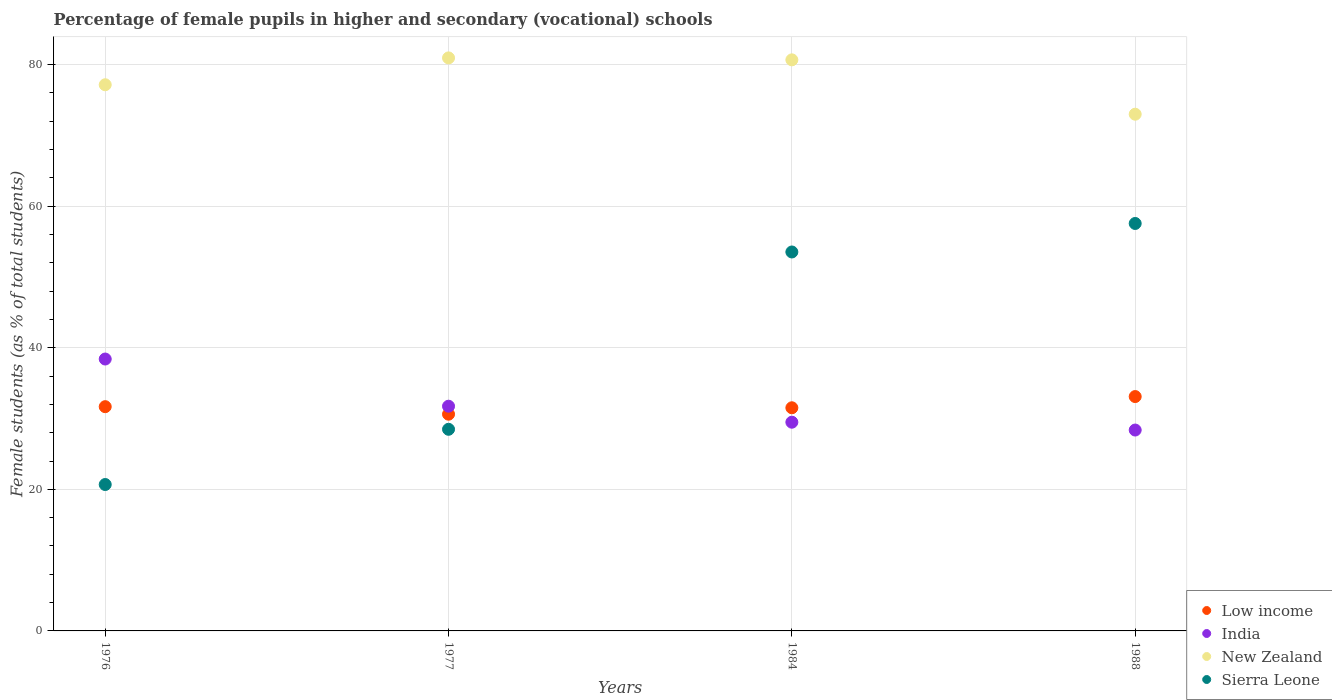What is the percentage of female pupils in higher and secondary schools in Low income in 1976?
Give a very brief answer. 31.67. Across all years, what is the maximum percentage of female pupils in higher and secondary schools in Sierra Leone?
Provide a short and direct response. 57.55. Across all years, what is the minimum percentage of female pupils in higher and secondary schools in Sierra Leone?
Give a very brief answer. 20.68. In which year was the percentage of female pupils in higher and secondary schools in India maximum?
Offer a terse response. 1976. In which year was the percentage of female pupils in higher and secondary schools in Low income minimum?
Ensure brevity in your answer.  1977. What is the total percentage of female pupils in higher and secondary schools in New Zealand in the graph?
Your response must be concise. 311.73. What is the difference between the percentage of female pupils in higher and secondary schools in Low income in 1976 and that in 1977?
Ensure brevity in your answer.  1.06. What is the difference between the percentage of female pupils in higher and secondary schools in Sierra Leone in 1988 and the percentage of female pupils in higher and secondary schools in India in 1976?
Keep it short and to the point. 19.15. What is the average percentage of female pupils in higher and secondary schools in New Zealand per year?
Make the answer very short. 77.93. In the year 1977, what is the difference between the percentage of female pupils in higher and secondary schools in Sierra Leone and percentage of female pupils in higher and secondary schools in India?
Offer a very short reply. -3.26. What is the ratio of the percentage of female pupils in higher and secondary schools in Low income in 1976 to that in 1984?
Your answer should be compact. 1. What is the difference between the highest and the second highest percentage of female pupils in higher and secondary schools in New Zealand?
Ensure brevity in your answer.  0.27. What is the difference between the highest and the lowest percentage of female pupils in higher and secondary schools in Low income?
Give a very brief answer. 2.49. In how many years, is the percentage of female pupils in higher and secondary schools in Sierra Leone greater than the average percentage of female pupils in higher and secondary schools in Sierra Leone taken over all years?
Give a very brief answer. 2. Is the sum of the percentage of female pupils in higher and secondary schools in Sierra Leone in 1976 and 1988 greater than the maximum percentage of female pupils in higher and secondary schools in New Zealand across all years?
Your response must be concise. No. Is it the case that in every year, the sum of the percentage of female pupils in higher and secondary schools in New Zealand and percentage of female pupils in higher and secondary schools in Low income  is greater than the sum of percentage of female pupils in higher and secondary schools in India and percentage of female pupils in higher and secondary schools in Sierra Leone?
Make the answer very short. Yes. Does the percentage of female pupils in higher and secondary schools in India monotonically increase over the years?
Your answer should be compact. No. Is the percentage of female pupils in higher and secondary schools in Low income strictly less than the percentage of female pupils in higher and secondary schools in Sierra Leone over the years?
Provide a succinct answer. No. How many years are there in the graph?
Make the answer very short. 4. Are the values on the major ticks of Y-axis written in scientific E-notation?
Keep it short and to the point. No. Does the graph contain any zero values?
Give a very brief answer. No. Does the graph contain grids?
Provide a short and direct response. Yes. How many legend labels are there?
Provide a short and direct response. 4. How are the legend labels stacked?
Your answer should be compact. Vertical. What is the title of the graph?
Your answer should be compact. Percentage of female pupils in higher and secondary (vocational) schools. Does "El Salvador" appear as one of the legend labels in the graph?
Offer a very short reply. No. What is the label or title of the X-axis?
Offer a terse response. Years. What is the label or title of the Y-axis?
Your response must be concise. Female students (as % of total students). What is the Female students (as % of total students) of Low income in 1976?
Your answer should be compact. 31.67. What is the Female students (as % of total students) of India in 1976?
Make the answer very short. 38.4. What is the Female students (as % of total students) of New Zealand in 1976?
Your response must be concise. 77.15. What is the Female students (as % of total students) of Sierra Leone in 1976?
Ensure brevity in your answer.  20.68. What is the Female students (as % of total students) of Low income in 1977?
Offer a terse response. 30.61. What is the Female students (as % of total students) in India in 1977?
Offer a very short reply. 31.74. What is the Female students (as % of total students) in New Zealand in 1977?
Keep it short and to the point. 80.94. What is the Female students (as % of total students) of Sierra Leone in 1977?
Offer a terse response. 28.48. What is the Female students (as % of total students) in Low income in 1984?
Give a very brief answer. 31.52. What is the Female students (as % of total students) in India in 1984?
Your answer should be compact. 29.48. What is the Female students (as % of total students) in New Zealand in 1984?
Ensure brevity in your answer.  80.66. What is the Female students (as % of total students) in Sierra Leone in 1984?
Your response must be concise. 53.52. What is the Female students (as % of total students) of Low income in 1988?
Keep it short and to the point. 33.1. What is the Female students (as % of total students) in India in 1988?
Your answer should be very brief. 28.37. What is the Female students (as % of total students) of New Zealand in 1988?
Make the answer very short. 72.98. What is the Female students (as % of total students) in Sierra Leone in 1988?
Your answer should be compact. 57.55. Across all years, what is the maximum Female students (as % of total students) in Low income?
Ensure brevity in your answer.  33.1. Across all years, what is the maximum Female students (as % of total students) of India?
Your answer should be compact. 38.4. Across all years, what is the maximum Female students (as % of total students) in New Zealand?
Ensure brevity in your answer.  80.94. Across all years, what is the maximum Female students (as % of total students) of Sierra Leone?
Offer a terse response. 57.55. Across all years, what is the minimum Female students (as % of total students) of Low income?
Offer a very short reply. 30.61. Across all years, what is the minimum Female students (as % of total students) of India?
Your answer should be compact. 28.37. Across all years, what is the minimum Female students (as % of total students) in New Zealand?
Provide a short and direct response. 72.98. Across all years, what is the minimum Female students (as % of total students) of Sierra Leone?
Offer a terse response. 20.68. What is the total Female students (as % of total students) of Low income in the graph?
Offer a terse response. 126.91. What is the total Female students (as % of total students) of India in the graph?
Your response must be concise. 128. What is the total Female students (as % of total students) of New Zealand in the graph?
Your answer should be very brief. 311.73. What is the total Female students (as % of total students) of Sierra Leone in the graph?
Keep it short and to the point. 160.24. What is the difference between the Female students (as % of total students) in Low income in 1976 and that in 1977?
Provide a succinct answer. 1.06. What is the difference between the Female students (as % of total students) of India in 1976 and that in 1977?
Offer a terse response. 6.66. What is the difference between the Female students (as % of total students) in New Zealand in 1976 and that in 1977?
Keep it short and to the point. -3.79. What is the difference between the Female students (as % of total students) in Sierra Leone in 1976 and that in 1977?
Keep it short and to the point. -7.8. What is the difference between the Female students (as % of total students) in Low income in 1976 and that in 1984?
Offer a terse response. 0.16. What is the difference between the Female students (as % of total students) in India in 1976 and that in 1984?
Give a very brief answer. 8.92. What is the difference between the Female students (as % of total students) of New Zealand in 1976 and that in 1984?
Ensure brevity in your answer.  -3.52. What is the difference between the Female students (as % of total students) of Sierra Leone in 1976 and that in 1984?
Your answer should be very brief. -32.85. What is the difference between the Female students (as % of total students) in Low income in 1976 and that in 1988?
Make the answer very short. -1.43. What is the difference between the Female students (as % of total students) in India in 1976 and that in 1988?
Provide a succinct answer. 10.03. What is the difference between the Female students (as % of total students) in New Zealand in 1976 and that in 1988?
Offer a very short reply. 4.16. What is the difference between the Female students (as % of total students) in Sierra Leone in 1976 and that in 1988?
Ensure brevity in your answer.  -36.87. What is the difference between the Female students (as % of total students) of Low income in 1977 and that in 1984?
Make the answer very short. -0.91. What is the difference between the Female students (as % of total students) of India in 1977 and that in 1984?
Your response must be concise. 2.26. What is the difference between the Female students (as % of total students) of New Zealand in 1977 and that in 1984?
Ensure brevity in your answer.  0.27. What is the difference between the Female students (as % of total students) of Sierra Leone in 1977 and that in 1984?
Ensure brevity in your answer.  -25.04. What is the difference between the Female students (as % of total students) in Low income in 1977 and that in 1988?
Make the answer very short. -2.49. What is the difference between the Female students (as % of total students) in India in 1977 and that in 1988?
Your response must be concise. 3.37. What is the difference between the Female students (as % of total students) of New Zealand in 1977 and that in 1988?
Offer a terse response. 7.95. What is the difference between the Female students (as % of total students) in Sierra Leone in 1977 and that in 1988?
Make the answer very short. -29.07. What is the difference between the Female students (as % of total students) in Low income in 1984 and that in 1988?
Keep it short and to the point. -1.58. What is the difference between the Female students (as % of total students) in India in 1984 and that in 1988?
Keep it short and to the point. 1.11. What is the difference between the Female students (as % of total students) in New Zealand in 1984 and that in 1988?
Offer a very short reply. 7.68. What is the difference between the Female students (as % of total students) in Sierra Leone in 1984 and that in 1988?
Ensure brevity in your answer.  -4.03. What is the difference between the Female students (as % of total students) of Low income in 1976 and the Female students (as % of total students) of India in 1977?
Ensure brevity in your answer.  -0.07. What is the difference between the Female students (as % of total students) of Low income in 1976 and the Female students (as % of total students) of New Zealand in 1977?
Keep it short and to the point. -49.26. What is the difference between the Female students (as % of total students) in Low income in 1976 and the Female students (as % of total students) in Sierra Leone in 1977?
Give a very brief answer. 3.19. What is the difference between the Female students (as % of total students) in India in 1976 and the Female students (as % of total students) in New Zealand in 1977?
Offer a very short reply. -42.53. What is the difference between the Female students (as % of total students) in India in 1976 and the Female students (as % of total students) in Sierra Leone in 1977?
Provide a succinct answer. 9.92. What is the difference between the Female students (as % of total students) in New Zealand in 1976 and the Female students (as % of total students) in Sierra Leone in 1977?
Offer a very short reply. 48.67. What is the difference between the Female students (as % of total students) of Low income in 1976 and the Female students (as % of total students) of India in 1984?
Your response must be concise. 2.19. What is the difference between the Female students (as % of total students) in Low income in 1976 and the Female students (as % of total students) in New Zealand in 1984?
Your answer should be compact. -48.99. What is the difference between the Female students (as % of total students) of Low income in 1976 and the Female students (as % of total students) of Sierra Leone in 1984?
Your response must be concise. -21.85. What is the difference between the Female students (as % of total students) in India in 1976 and the Female students (as % of total students) in New Zealand in 1984?
Your answer should be compact. -42.26. What is the difference between the Female students (as % of total students) of India in 1976 and the Female students (as % of total students) of Sierra Leone in 1984?
Ensure brevity in your answer.  -15.12. What is the difference between the Female students (as % of total students) of New Zealand in 1976 and the Female students (as % of total students) of Sierra Leone in 1984?
Give a very brief answer. 23.62. What is the difference between the Female students (as % of total students) in Low income in 1976 and the Female students (as % of total students) in India in 1988?
Your answer should be very brief. 3.3. What is the difference between the Female students (as % of total students) in Low income in 1976 and the Female students (as % of total students) in New Zealand in 1988?
Your answer should be very brief. -41.31. What is the difference between the Female students (as % of total students) of Low income in 1976 and the Female students (as % of total students) of Sierra Leone in 1988?
Your response must be concise. -25.88. What is the difference between the Female students (as % of total students) in India in 1976 and the Female students (as % of total students) in New Zealand in 1988?
Your answer should be very brief. -34.58. What is the difference between the Female students (as % of total students) in India in 1976 and the Female students (as % of total students) in Sierra Leone in 1988?
Give a very brief answer. -19.15. What is the difference between the Female students (as % of total students) of New Zealand in 1976 and the Female students (as % of total students) of Sierra Leone in 1988?
Your answer should be very brief. 19.59. What is the difference between the Female students (as % of total students) in Low income in 1977 and the Female students (as % of total students) in India in 1984?
Provide a short and direct response. 1.13. What is the difference between the Female students (as % of total students) of Low income in 1977 and the Female students (as % of total students) of New Zealand in 1984?
Offer a terse response. -50.05. What is the difference between the Female students (as % of total students) of Low income in 1977 and the Female students (as % of total students) of Sierra Leone in 1984?
Your answer should be very brief. -22.91. What is the difference between the Female students (as % of total students) of India in 1977 and the Female students (as % of total students) of New Zealand in 1984?
Your answer should be very brief. -48.92. What is the difference between the Female students (as % of total students) in India in 1977 and the Female students (as % of total students) in Sierra Leone in 1984?
Give a very brief answer. -21.79. What is the difference between the Female students (as % of total students) in New Zealand in 1977 and the Female students (as % of total students) in Sierra Leone in 1984?
Give a very brief answer. 27.41. What is the difference between the Female students (as % of total students) of Low income in 1977 and the Female students (as % of total students) of India in 1988?
Your response must be concise. 2.24. What is the difference between the Female students (as % of total students) of Low income in 1977 and the Female students (as % of total students) of New Zealand in 1988?
Ensure brevity in your answer.  -42.37. What is the difference between the Female students (as % of total students) of Low income in 1977 and the Female students (as % of total students) of Sierra Leone in 1988?
Offer a terse response. -26.94. What is the difference between the Female students (as % of total students) of India in 1977 and the Female students (as % of total students) of New Zealand in 1988?
Provide a short and direct response. -41.24. What is the difference between the Female students (as % of total students) of India in 1977 and the Female students (as % of total students) of Sierra Leone in 1988?
Offer a very short reply. -25.81. What is the difference between the Female students (as % of total students) of New Zealand in 1977 and the Female students (as % of total students) of Sierra Leone in 1988?
Make the answer very short. 23.39. What is the difference between the Female students (as % of total students) of Low income in 1984 and the Female students (as % of total students) of India in 1988?
Make the answer very short. 3.14. What is the difference between the Female students (as % of total students) in Low income in 1984 and the Female students (as % of total students) in New Zealand in 1988?
Your answer should be compact. -41.47. What is the difference between the Female students (as % of total students) of Low income in 1984 and the Female students (as % of total students) of Sierra Leone in 1988?
Your answer should be compact. -26.03. What is the difference between the Female students (as % of total students) in India in 1984 and the Female students (as % of total students) in New Zealand in 1988?
Ensure brevity in your answer.  -43.5. What is the difference between the Female students (as % of total students) of India in 1984 and the Female students (as % of total students) of Sierra Leone in 1988?
Give a very brief answer. -28.07. What is the difference between the Female students (as % of total students) of New Zealand in 1984 and the Female students (as % of total students) of Sierra Leone in 1988?
Offer a terse response. 23.11. What is the average Female students (as % of total students) of Low income per year?
Give a very brief answer. 31.73. What is the average Female students (as % of total students) of India per year?
Offer a terse response. 32. What is the average Female students (as % of total students) in New Zealand per year?
Provide a succinct answer. 77.93. What is the average Female students (as % of total students) of Sierra Leone per year?
Your response must be concise. 40.06. In the year 1976, what is the difference between the Female students (as % of total students) in Low income and Female students (as % of total students) in India?
Your response must be concise. -6.73. In the year 1976, what is the difference between the Female students (as % of total students) of Low income and Female students (as % of total students) of New Zealand?
Provide a succinct answer. -45.47. In the year 1976, what is the difference between the Female students (as % of total students) of Low income and Female students (as % of total students) of Sierra Leone?
Offer a very short reply. 11. In the year 1976, what is the difference between the Female students (as % of total students) in India and Female students (as % of total students) in New Zealand?
Provide a short and direct response. -38.74. In the year 1976, what is the difference between the Female students (as % of total students) in India and Female students (as % of total students) in Sierra Leone?
Make the answer very short. 17.73. In the year 1976, what is the difference between the Female students (as % of total students) in New Zealand and Female students (as % of total students) in Sierra Leone?
Provide a succinct answer. 56.47. In the year 1977, what is the difference between the Female students (as % of total students) of Low income and Female students (as % of total students) of India?
Your answer should be very brief. -1.13. In the year 1977, what is the difference between the Female students (as % of total students) of Low income and Female students (as % of total students) of New Zealand?
Provide a short and direct response. -50.33. In the year 1977, what is the difference between the Female students (as % of total students) in Low income and Female students (as % of total students) in Sierra Leone?
Your response must be concise. 2.13. In the year 1977, what is the difference between the Female students (as % of total students) of India and Female students (as % of total students) of New Zealand?
Ensure brevity in your answer.  -49.2. In the year 1977, what is the difference between the Female students (as % of total students) in India and Female students (as % of total students) in Sierra Leone?
Give a very brief answer. 3.26. In the year 1977, what is the difference between the Female students (as % of total students) in New Zealand and Female students (as % of total students) in Sierra Leone?
Your answer should be compact. 52.46. In the year 1984, what is the difference between the Female students (as % of total students) of Low income and Female students (as % of total students) of India?
Ensure brevity in your answer.  2.04. In the year 1984, what is the difference between the Female students (as % of total students) of Low income and Female students (as % of total students) of New Zealand?
Your answer should be very brief. -49.14. In the year 1984, what is the difference between the Female students (as % of total students) in Low income and Female students (as % of total students) in Sierra Leone?
Your answer should be compact. -22.01. In the year 1984, what is the difference between the Female students (as % of total students) of India and Female students (as % of total students) of New Zealand?
Make the answer very short. -51.18. In the year 1984, what is the difference between the Female students (as % of total students) of India and Female students (as % of total students) of Sierra Leone?
Ensure brevity in your answer.  -24.04. In the year 1984, what is the difference between the Female students (as % of total students) in New Zealand and Female students (as % of total students) in Sierra Leone?
Ensure brevity in your answer.  27.14. In the year 1988, what is the difference between the Female students (as % of total students) of Low income and Female students (as % of total students) of India?
Keep it short and to the point. 4.73. In the year 1988, what is the difference between the Female students (as % of total students) in Low income and Female students (as % of total students) in New Zealand?
Ensure brevity in your answer.  -39.88. In the year 1988, what is the difference between the Female students (as % of total students) in Low income and Female students (as % of total students) in Sierra Leone?
Make the answer very short. -24.45. In the year 1988, what is the difference between the Female students (as % of total students) in India and Female students (as % of total students) in New Zealand?
Ensure brevity in your answer.  -44.61. In the year 1988, what is the difference between the Female students (as % of total students) in India and Female students (as % of total students) in Sierra Leone?
Offer a terse response. -29.18. In the year 1988, what is the difference between the Female students (as % of total students) of New Zealand and Female students (as % of total students) of Sierra Leone?
Provide a succinct answer. 15.43. What is the ratio of the Female students (as % of total students) in Low income in 1976 to that in 1977?
Offer a terse response. 1.03. What is the ratio of the Female students (as % of total students) of India in 1976 to that in 1977?
Provide a succinct answer. 1.21. What is the ratio of the Female students (as % of total students) in New Zealand in 1976 to that in 1977?
Your answer should be compact. 0.95. What is the ratio of the Female students (as % of total students) of Sierra Leone in 1976 to that in 1977?
Give a very brief answer. 0.73. What is the ratio of the Female students (as % of total students) of Low income in 1976 to that in 1984?
Your answer should be compact. 1. What is the ratio of the Female students (as % of total students) in India in 1976 to that in 1984?
Your response must be concise. 1.3. What is the ratio of the Female students (as % of total students) in New Zealand in 1976 to that in 1984?
Give a very brief answer. 0.96. What is the ratio of the Female students (as % of total students) in Sierra Leone in 1976 to that in 1984?
Ensure brevity in your answer.  0.39. What is the ratio of the Female students (as % of total students) in Low income in 1976 to that in 1988?
Keep it short and to the point. 0.96. What is the ratio of the Female students (as % of total students) of India in 1976 to that in 1988?
Your answer should be compact. 1.35. What is the ratio of the Female students (as % of total students) in New Zealand in 1976 to that in 1988?
Ensure brevity in your answer.  1.06. What is the ratio of the Female students (as % of total students) in Sierra Leone in 1976 to that in 1988?
Ensure brevity in your answer.  0.36. What is the ratio of the Female students (as % of total students) in Low income in 1977 to that in 1984?
Offer a very short reply. 0.97. What is the ratio of the Female students (as % of total students) in India in 1977 to that in 1984?
Offer a very short reply. 1.08. What is the ratio of the Female students (as % of total students) of Sierra Leone in 1977 to that in 1984?
Your answer should be very brief. 0.53. What is the ratio of the Female students (as % of total students) in Low income in 1977 to that in 1988?
Provide a short and direct response. 0.92. What is the ratio of the Female students (as % of total students) of India in 1977 to that in 1988?
Provide a short and direct response. 1.12. What is the ratio of the Female students (as % of total students) of New Zealand in 1977 to that in 1988?
Your response must be concise. 1.11. What is the ratio of the Female students (as % of total students) of Sierra Leone in 1977 to that in 1988?
Offer a very short reply. 0.49. What is the ratio of the Female students (as % of total students) in Low income in 1984 to that in 1988?
Your answer should be very brief. 0.95. What is the ratio of the Female students (as % of total students) in India in 1984 to that in 1988?
Provide a succinct answer. 1.04. What is the ratio of the Female students (as % of total students) in New Zealand in 1984 to that in 1988?
Keep it short and to the point. 1.11. What is the ratio of the Female students (as % of total students) of Sierra Leone in 1984 to that in 1988?
Offer a very short reply. 0.93. What is the difference between the highest and the second highest Female students (as % of total students) of Low income?
Your answer should be compact. 1.43. What is the difference between the highest and the second highest Female students (as % of total students) of India?
Give a very brief answer. 6.66. What is the difference between the highest and the second highest Female students (as % of total students) of New Zealand?
Your answer should be compact. 0.27. What is the difference between the highest and the second highest Female students (as % of total students) in Sierra Leone?
Make the answer very short. 4.03. What is the difference between the highest and the lowest Female students (as % of total students) in Low income?
Make the answer very short. 2.49. What is the difference between the highest and the lowest Female students (as % of total students) in India?
Give a very brief answer. 10.03. What is the difference between the highest and the lowest Female students (as % of total students) of New Zealand?
Ensure brevity in your answer.  7.95. What is the difference between the highest and the lowest Female students (as % of total students) in Sierra Leone?
Provide a short and direct response. 36.87. 